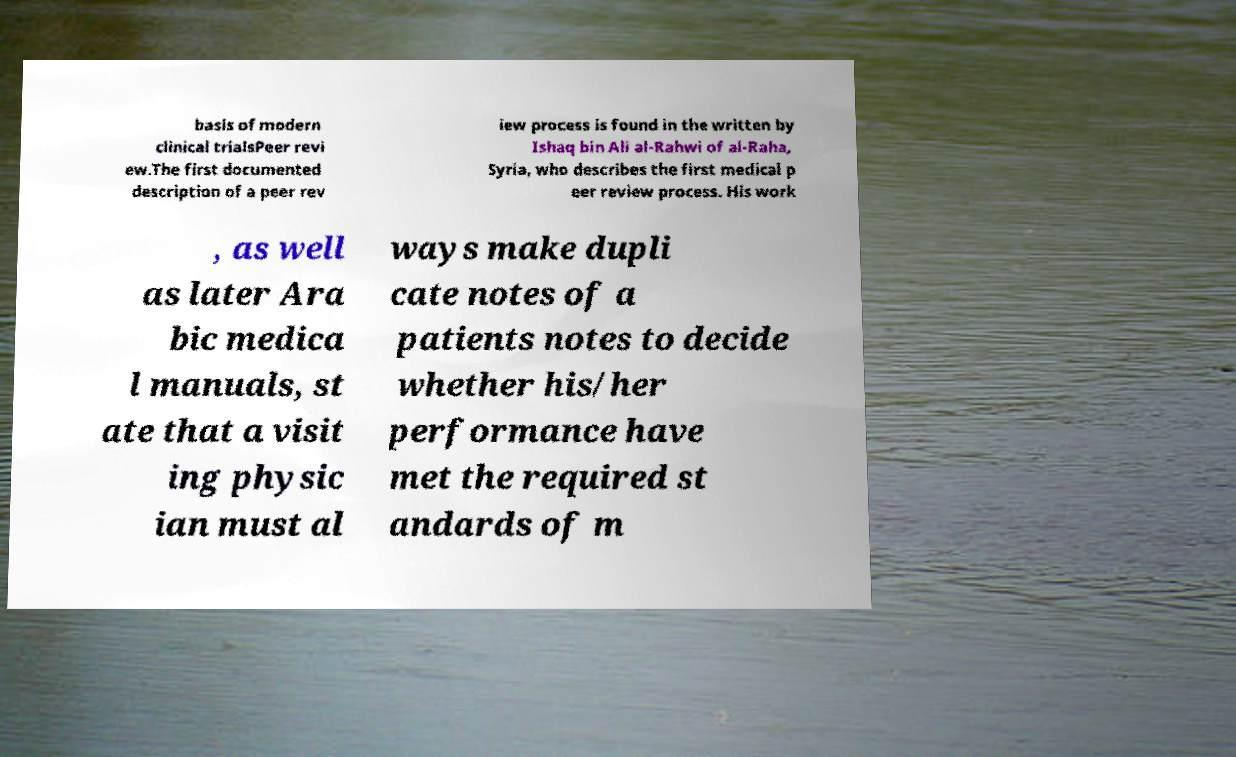For documentation purposes, I need the text within this image transcribed. Could you provide that? basis of modern clinical trialsPeer revi ew.The first documented description of a peer rev iew process is found in the written by Ishaq bin Ali al-Rahwi of al-Raha, Syria, who describes the first medical p eer review process. His work , as well as later Ara bic medica l manuals, st ate that a visit ing physic ian must al ways make dupli cate notes of a patients notes to decide whether his/her performance have met the required st andards of m 